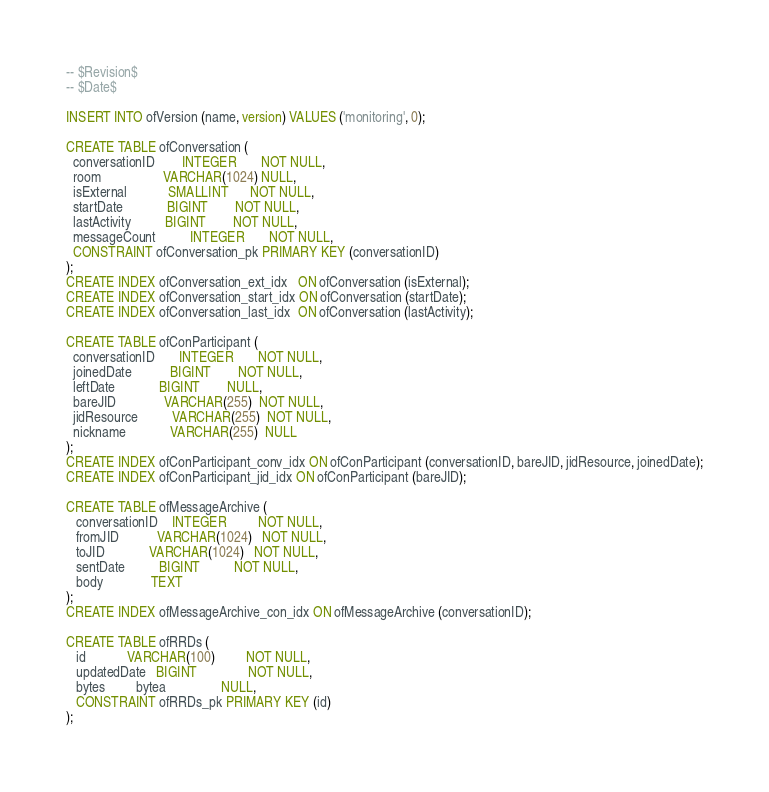Convert code to text. <code><loc_0><loc_0><loc_500><loc_500><_SQL_>-- $Revision$
-- $Date$

INSERT INTO ofVersion (name, version) VALUES ('monitoring', 0);

CREATE TABLE ofConversation (
  conversationID        INTEGER       NOT NULL,
  room                  VARCHAR(1024) NULL,
  isExternal            SMALLINT      NOT NULL,
  startDate             BIGINT        NOT NULL,
  lastActivity          BIGINT        NOT NULL,
  messageCount          INTEGER       NOT NULL,
  CONSTRAINT ofConversation_pk PRIMARY KEY (conversationID)
);
CREATE INDEX ofConversation_ext_idx   ON ofConversation (isExternal);
CREATE INDEX ofConversation_start_idx ON ofConversation (startDate);
CREATE INDEX ofConversation_last_idx  ON ofConversation (lastActivity);

CREATE TABLE ofConParticipant (
  conversationID       INTEGER       NOT NULL,
  joinedDate           BIGINT        NOT NULL,
  leftDate             BIGINT        NULL,
  bareJID              VARCHAR(255)  NOT NULL,
  jidResource          VARCHAR(255)  NOT NULL,
  nickname             VARCHAR(255)  NULL
);
CREATE INDEX ofConParticipant_conv_idx ON ofConParticipant (conversationID, bareJID, jidResource, joinedDate);
CREATE INDEX ofConParticipant_jid_idx ON ofConParticipant (bareJID);

CREATE TABLE ofMessageArchive (
   conversationID    INTEGER         NOT NULL,
   fromJID           VARCHAR(1024)   NOT NULL,
   toJID             VARCHAR(1024)   NOT NULL,
   sentDate          BIGINT          NOT NULL,
   body              TEXT
);
CREATE INDEX ofMessageArchive_con_idx ON ofMessageArchive (conversationID);

CREATE TABLE ofRRDs (
   id            VARCHAR(100)         NOT NULL,
   updatedDate   BIGINT               NOT NULL,
   bytes         bytea                NULL,
   CONSTRAINT ofRRDs_pk PRIMARY KEY (id)
);

</code> 